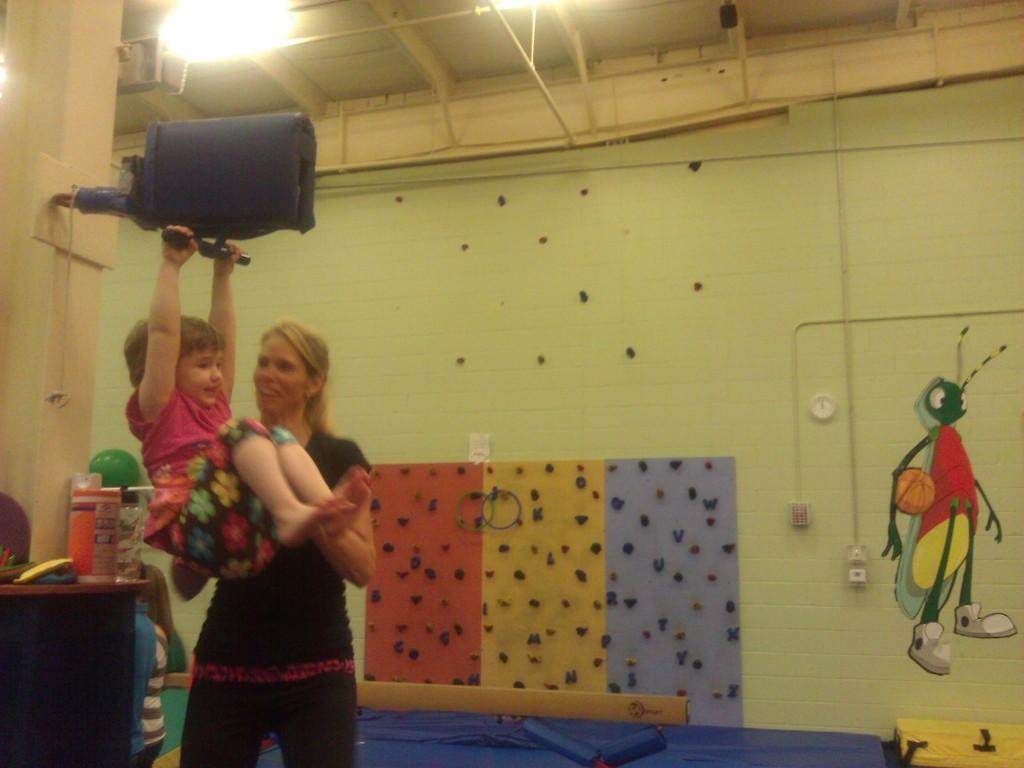In one or two sentences, can you explain what this image depicts? In this picture there is a woman who is holding a baby and she is holding a bag. At the bottom I can see the blue carpets. On the left I can see a girl who is the standing near to the table. In the back I can see the sockets, wires, painting and other objects. At the top we can see the lights. 